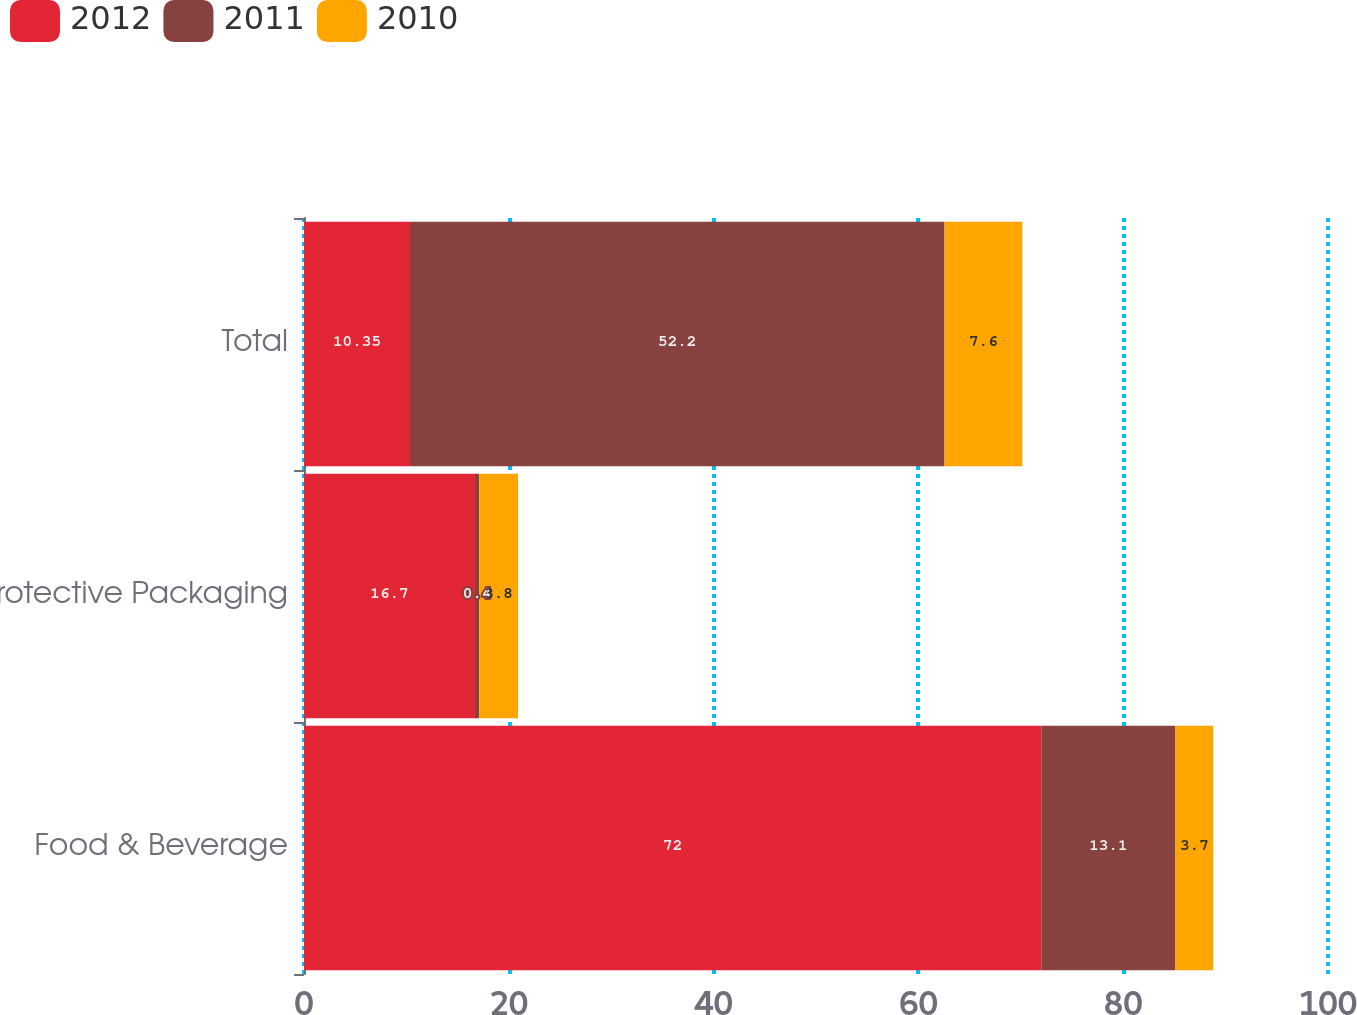<chart> <loc_0><loc_0><loc_500><loc_500><stacked_bar_chart><ecel><fcel>Food & Beverage<fcel>Protective Packaging<fcel>Total<nl><fcel>2012<fcel>72<fcel>16.7<fcel>10.35<nl><fcel>2011<fcel>13.1<fcel>0.4<fcel>52.2<nl><fcel>2010<fcel>3.7<fcel>3.8<fcel>7.6<nl></chart> 